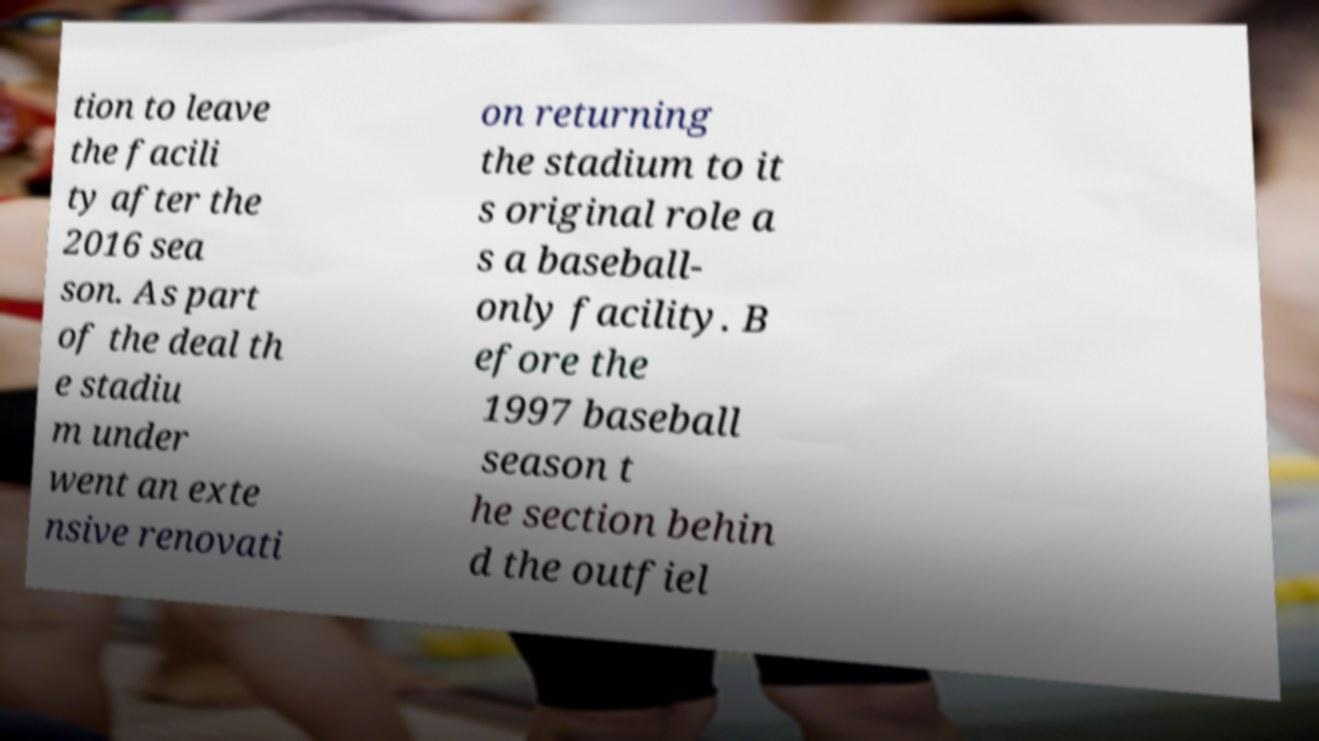There's text embedded in this image that I need extracted. Can you transcribe it verbatim? tion to leave the facili ty after the 2016 sea son. As part of the deal th e stadiu m under went an exte nsive renovati on returning the stadium to it s original role a s a baseball- only facility. B efore the 1997 baseball season t he section behin d the outfiel 